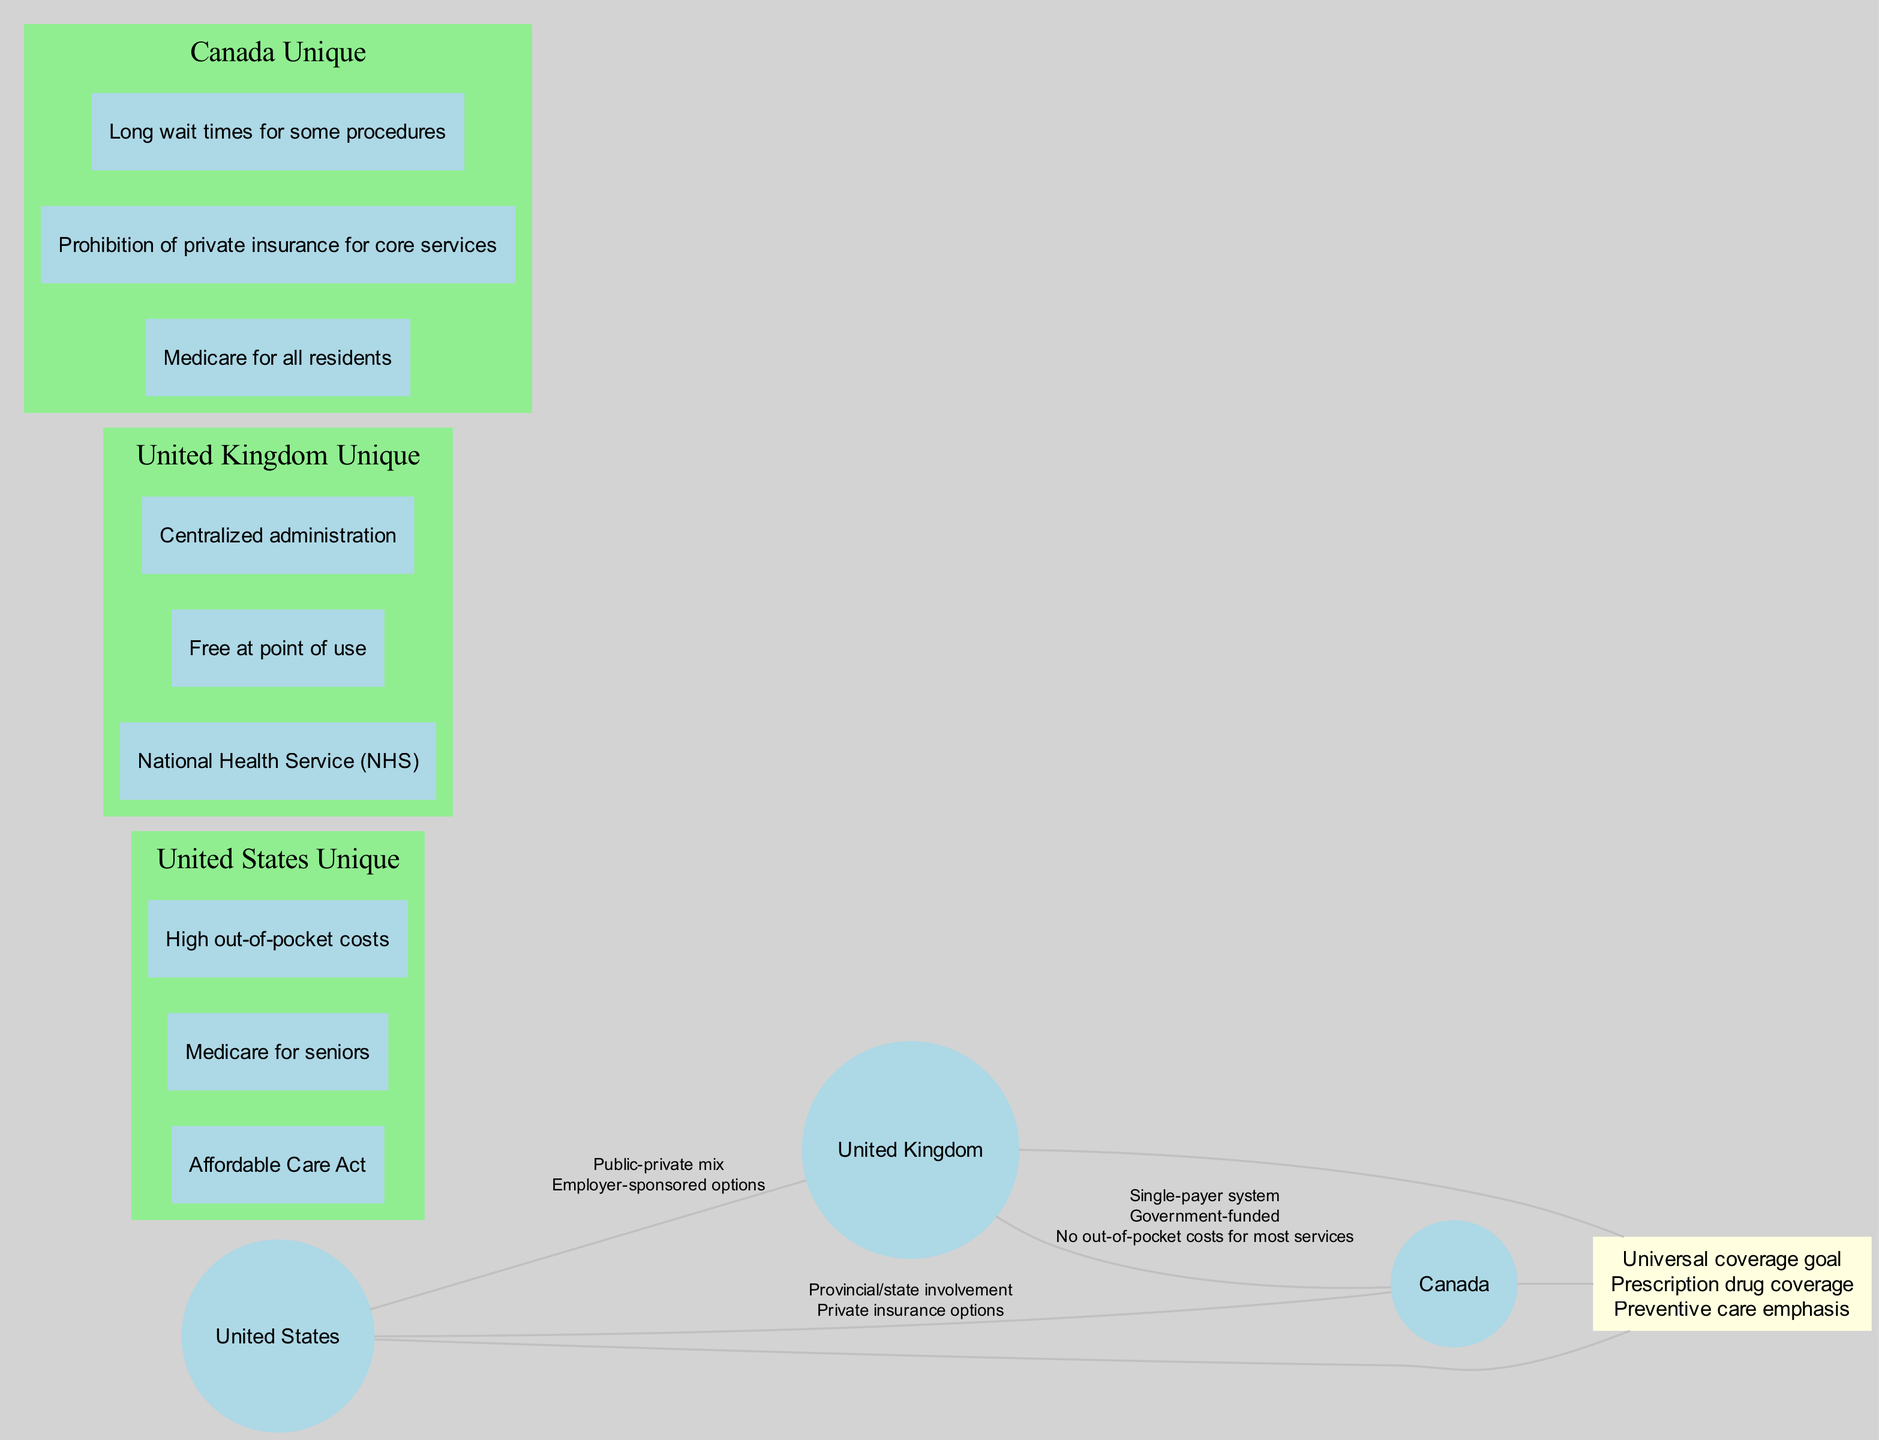What are the unique elements of the United Kingdom's healthcare system? The diagram shows three unique elements directly associated with the United Kingdom: "National Health Service (NHS)," "Free at point of use," and "Centralized administration." These are represented in a green-shaded area specifically for the UK.
Answer: National Health Service (NHS), Free at point of use, Centralized administration Which two countries share the 'Single-payer system' feature? The diagram indicates that the 'Single-payer system' is present in the intersection between the United Kingdom and Canada. By checking the sectors of the Venn diagram where these two countries overlap, we confirm this feature is listed there.
Answer: United Kingdom and Canada How many elements are shared by all three countries in the central intersection? The center area where all three countries overlap contains three elements: "Universal coverage goal," "Prescription drug coverage," and "Preventive care emphasis." Thus, counting these elements gives the total number.
Answer: 3 What unique aspect distinguishes Canada from the United States according to the diagram? Looking at the unique elements for each country, Canada is characterized by "Prohibition of private insurance for core services." This statement is not found among the unique elements listed for the United States, thus highlighting their difference.
Answer: Prohibition of private insurance for core services How many elements do the United States and United Kingdom share that are not present in Canada? By examining the shared elements specifically between the United States and the United Kingdom, we identify two elements: "Public-private mix" and "Employer-sponsored options." These elements are not mentioned in the intersection with Canada. Counting these gives the answer to the question.
Answer: 2 What does the diagram imply about out-of-pocket costs in the United Kingdom compared to the United States? The unique elements for the United Kingdom state "No out-of-pocket costs for most services," while the United States states "High out-of-pocket costs." This implies a significant difference in the financial burden on patients between these two systems.
Answer: No out-of-pocket costs for most services and High out-of-pocket costs Which feature is emphasized by all three countries in their healthcare system? The Venn diagram shows that elements like "Universal coverage goal," "Prescription drug coverage," and "Preventive care emphasis" are located in the intersection where all three countries converge. Thus, these are the common features emphasized by the three.
Answer: Universal coverage goal, Prescription drug coverage, Preventive care emphasis What is the total number of countries represented in the diagram? The diagram lists three distinct countries: the United States, the United Kingdom, and Canada. Therefore, counting these gives the total number of countries present in the diagram.
Answer: 3 